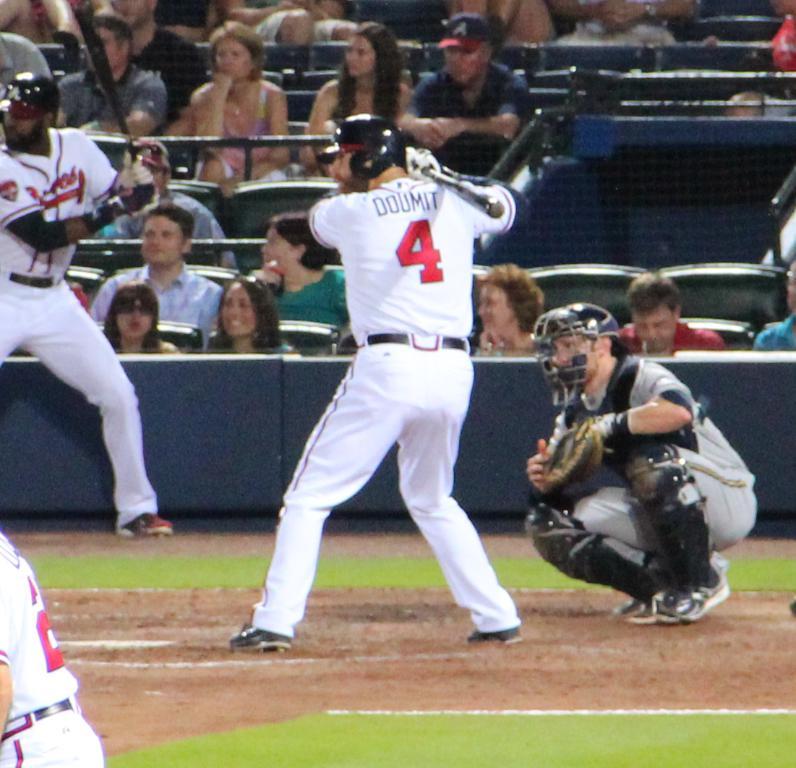What is the name on the batter's jersey?
Keep it short and to the point. Doumit. 